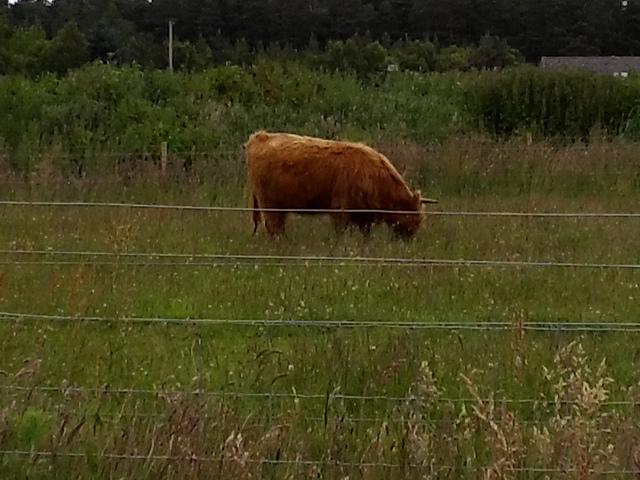Is the animal standing?
Keep it brief. Yes. What color is the animal?
Be succinct. Brown. How many animals are there?
Short answer required. 1. On which side of the animal is the house?
Quick response, please. Right. Does this belong here?
Short answer required. Yes. Is an animal grazing?
Quick response, please. Yes. 